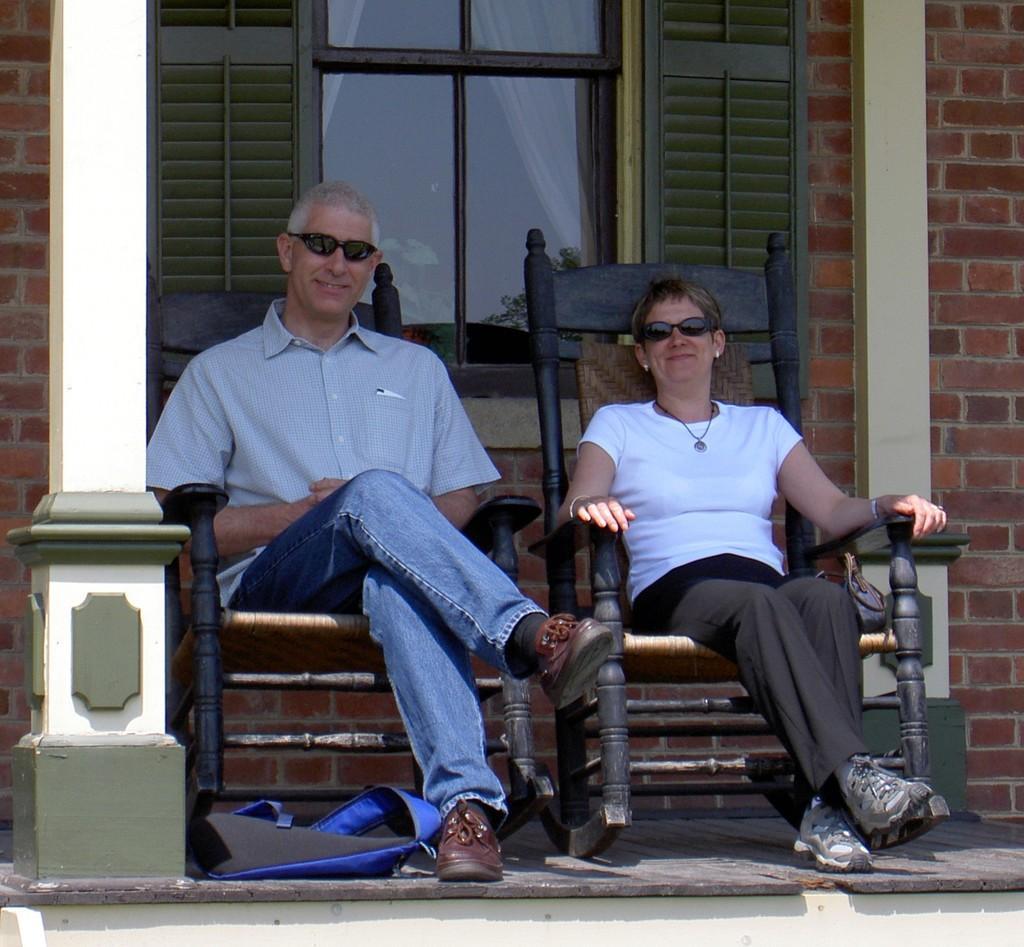Can you describe this image briefly? In this image there are two person sitting on the chair. On the floor there is a bag. At the back side we can see a building and a window. 